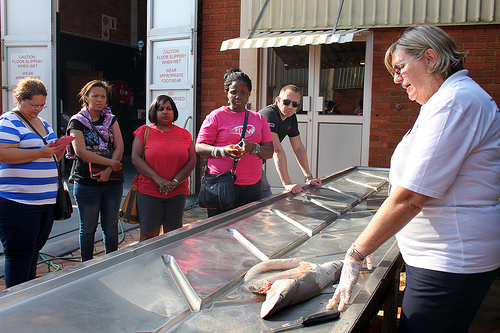<image>
Is there a man to the left of the table? Yes. From this viewpoint, the man is positioned to the left side relative to the table. Is the fish under the purse? No. The fish is not positioned under the purse. The vertical relationship between these objects is different. Is there a fish in front of the woman? Yes. The fish is positioned in front of the woman, appearing closer to the camera viewpoint. 